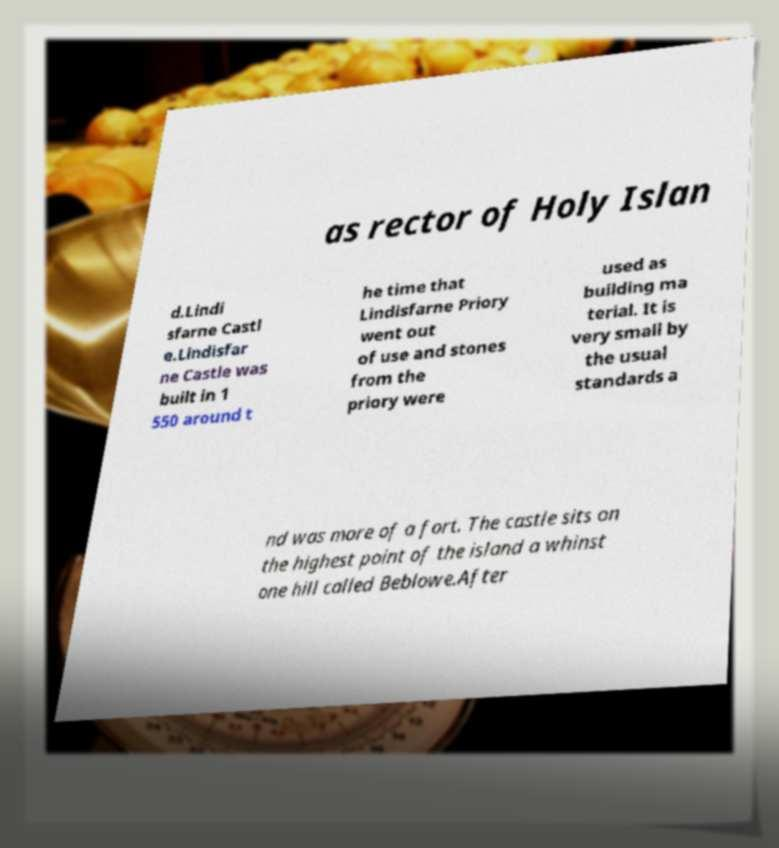Could you extract and type out the text from this image? as rector of Holy Islan d.Lindi sfarne Castl e.Lindisfar ne Castle was built in 1 550 around t he time that Lindisfarne Priory went out of use and stones from the priory were used as building ma terial. It is very small by the usual standards a nd was more of a fort. The castle sits on the highest point of the island a whinst one hill called Beblowe.After 